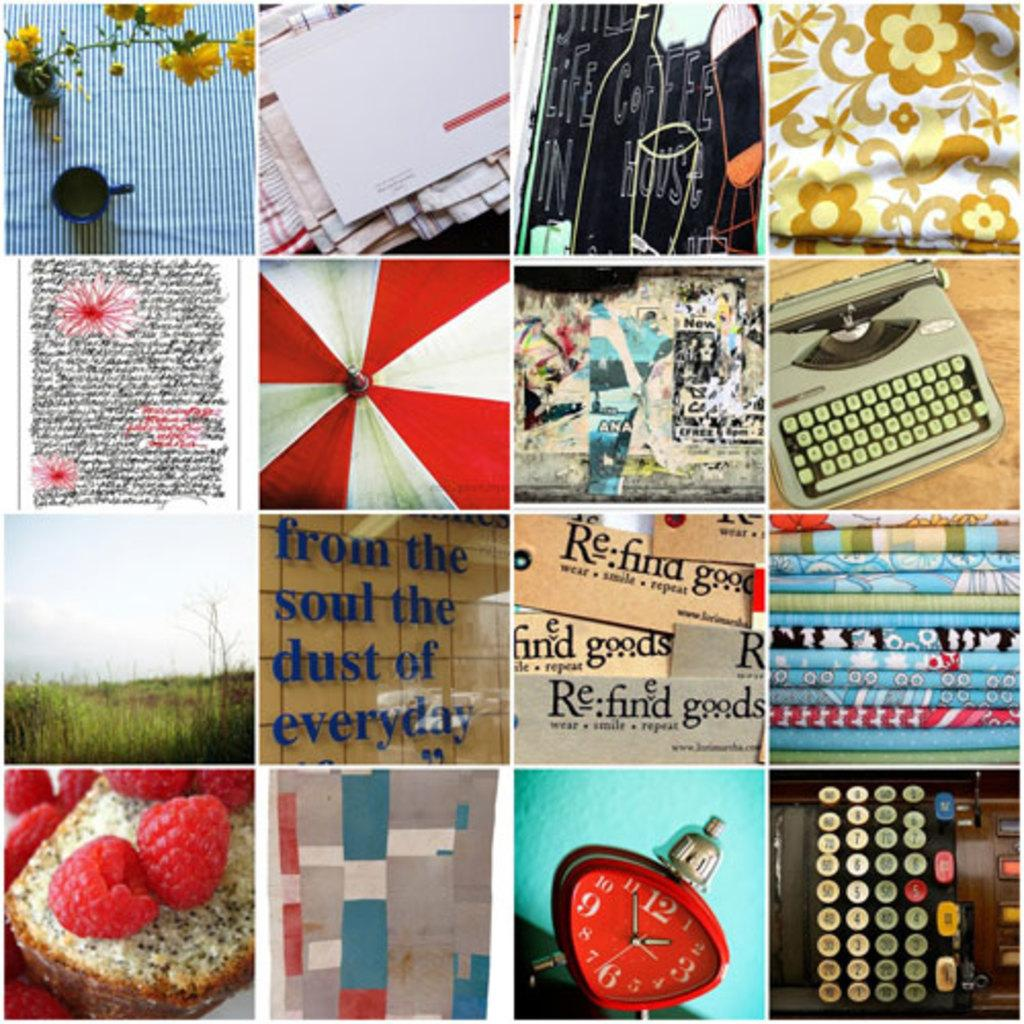What types of items can be found in the collage? There are food items, text, a flower vase, a device, a cup, clothes, and grass in the collage. Can you describe the text in the collage? Unfortunately, the specific text in the collage cannot be determined from the given facts. What kind of device is present in the collage? The facts do not specify the type of device in the collage. Are there any natural elements in the collage? Yes, there is grass in the collage, which is a natural element. How many daughters are depicted in the collage? There is no mention of a daughter or any people in the collage; it contains various objects and elements. What type of tongue can be seen in the collage? There is no tongue present in the collage; it contains food items, text, a flower vase, a device, a cup, clothes, and grass. 